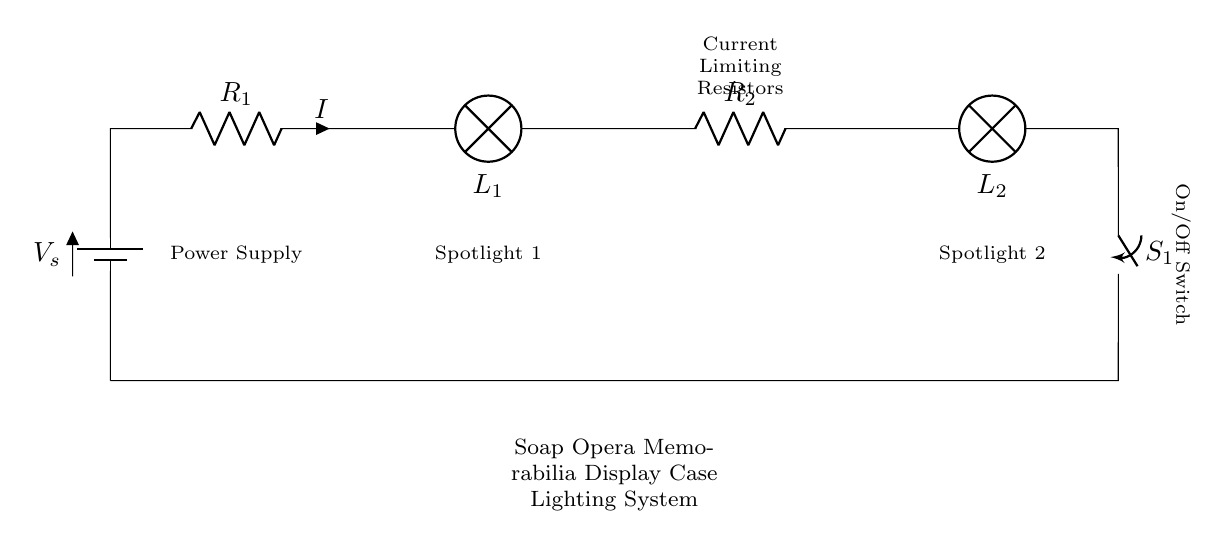What type of circuit is displayed? The circuit is a series circuit, where all components are connected end-to-end, providing a single path for current to flow.
Answer: Series What is the purpose of the resistors in this circuit? The resistors are current limiting resistors, which are used to reduce the current flowing through the lamps in order to prevent them from burning out.
Answer: Current limiting How many lamps are present in the circuit? There are two lamps (L1 and L2) shown in the diagram, which provide lighting for the display case.
Answer: Two What happens when the switch is closed? When the switch (S1) is closed, it completes the circuit, allowing current to flow through the lamps, which will turn them on.
Answer: Turns on lights What is the name of the power supply in this circuit? The power supply is labeled as V_s, representing the voltage source that powers the entire circuit.
Answer: V_s What is the current flowing through the circuit denoted as? The current flowing through the circuit is denoted as I, which is indicated next to the resistor R1.
Answer: I Where are the spotlights placed in the circuit? The spotlights (L1 and L2) are connected in series after the resistors, contributing to the direct path of current flow in the circuit.
Answer: After resistors 